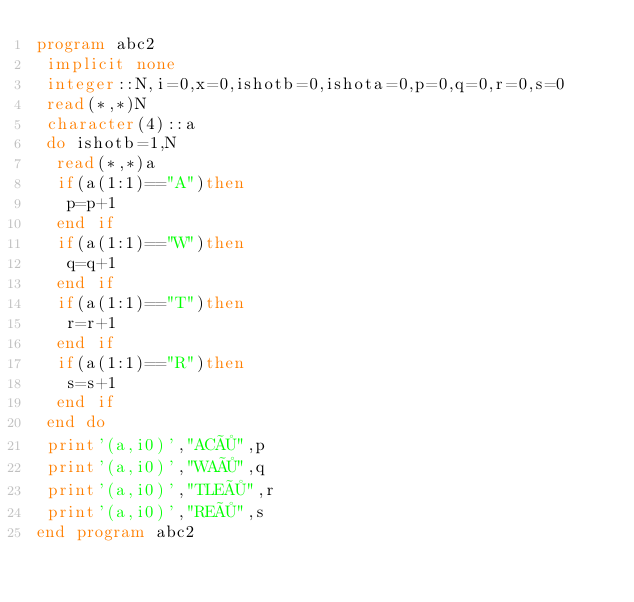<code> <loc_0><loc_0><loc_500><loc_500><_FORTRAN_>program abc2
 implicit none
 integer::N,i=0,x=0,ishotb=0,ishota=0,p=0,q=0,r=0,s=0
 read(*,*)N
 character(4)::a
 do ishotb=1,N
  read(*,*)a
  if(a(1:1)=="A")then
   p=p+1
  end if
  if(a(1:1)=="W")then
   q=q+1
  end if
  if(a(1:1)=="T")then
   r=r+1
  end if
  if(a(1:1)=="R")then
   s=s+1
  end if
 end do
 print'(a,i0)',"AC×",p
 print'(a,i0)',"WA×",q
 print'(a,i0)',"TLE×",r
 print'(a,i0)',"RE×",s
end program abc2</code> 